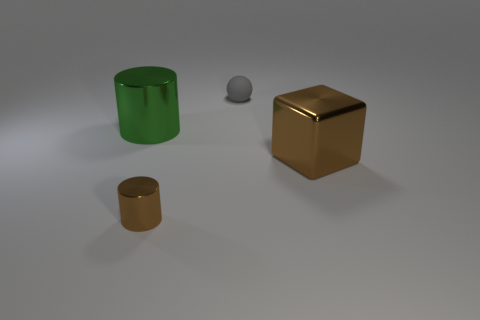Is there any other thing that is made of the same material as the large cylinder?
Ensure brevity in your answer.  Yes. There is a cylinder in front of the green object; what is its color?
Provide a succinct answer. Brown. Is the number of large green metal objects left of the large metal cylinder the same as the number of large green shiny objects?
Make the answer very short. No. How many other objects are there of the same shape as the small metal object?
Your response must be concise. 1. There is a large green cylinder; how many metal cylinders are to the right of it?
Ensure brevity in your answer.  1. What is the size of the object that is to the left of the tiny gray matte sphere and in front of the green cylinder?
Provide a succinct answer. Small. Is there a small gray rubber thing?
Make the answer very short. Yes. What number of other objects are there of the same size as the rubber thing?
Your response must be concise. 1. There is a tiny thing that is in front of the large green object; is it the same color as the large metallic object right of the small rubber thing?
Your answer should be compact. Yes. What size is the brown object that is the same shape as the big green metallic object?
Make the answer very short. Small. 